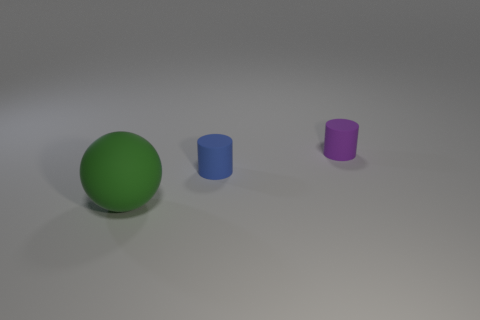Add 2 small blue cylinders. How many objects exist? 5 Subtract all purple cylinders. How many cylinders are left? 1 Subtract all spheres. How many objects are left? 2 Subtract 1 cylinders. How many cylinders are left? 1 Subtract all brown balls. Subtract all red blocks. How many balls are left? 1 Subtract all blue spheres. How many blue cylinders are left? 1 Subtract all tiny cyan spheres. Subtract all green balls. How many objects are left? 2 Add 2 tiny cylinders. How many tiny cylinders are left? 4 Add 1 blue cylinders. How many blue cylinders exist? 2 Subtract 0 blue blocks. How many objects are left? 3 